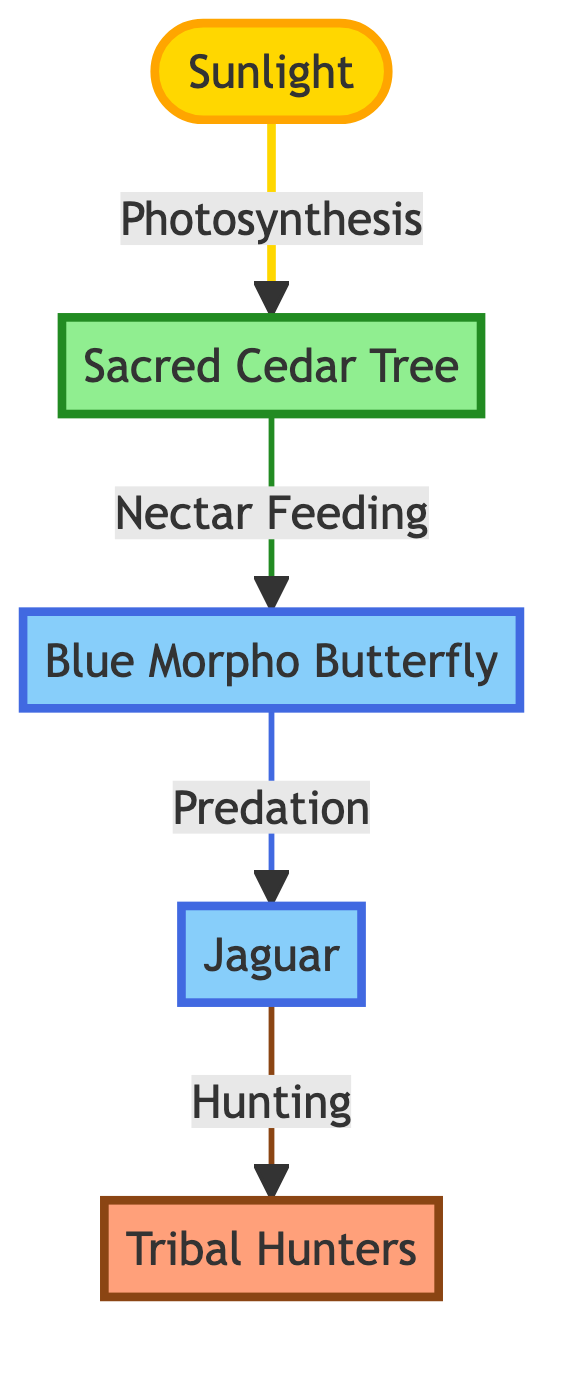What is the first node in the flow? The first node in the flow is represented by sunlight, which indicates that sunlight is the initial source of energy for the food chain process.
Answer: Sunlight How many nodes are in the diagram? To find the total number of nodes, we count each unique entity in the diagram: sunlight, sacred cedar tree, blue morpho butterfly, jaguar, and tribal hunters, totaling five nodes.
Answer: 5 What type of relationship exists between the sacred cedar tree and the blue morpho butterfly? The relationship between the sacred cedar tree and the blue morpho butterfly is marked as "Nectar Feeding," indicating that the butterfly feeds on nectar produced by the cedar tree.
Answer: Nectar Feeding Who benefits from the predation on the blue morpho butterfly? The diagram shows that the jaguar benefits from the predation on the blue morpho butterfly, as it is the entity that hunts the butterfly for food.
Answer: Jaguar What process does the sacred cedar tree use to grow? The sacred cedar tree utilizes photosynthesis, a process shown in the diagram that enables it to convert sunlight into energy, aiding its growth.
Answer: Photosynthesis Which entity is at the end of the food chain? The end of the food chain is represented by tribal hunters, who are the last node in the flow, indicating they hunt the jaguar.
Answer: Tribal Hunters What two types of entities does the sacred cedar tree connect to in the food chain? The sacred cedar tree connects to the blue morpho butterfly and sunlight, as it directly interacts with both by using sunlight for photosynthesis and providing nectar to the butterfly.
Answer: Blue Morpho Butterfly and Sunlight If the jaguar's population decreases, who will be directly affected? If the jaguar's population decreases, the blue morpho butterfly population may increase because there would be less predation on them from the jaguar, affecting the balance of the ecosystem.
Answer: Blue Morpho Butterfly What is the relationship direction between sunlight and the sacred cedar tree? The relationship direction from sunlight to the sacred cedar tree is described as an input for photosynthesis, where sunlight is necessary for the tree's process of energy conversion.
Answer: Photosynthesis 